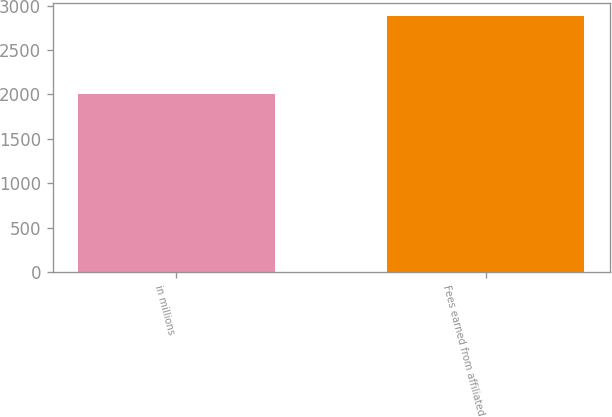<chart> <loc_0><loc_0><loc_500><loc_500><bar_chart><fcel>in millions<fcel>Fees earned from affiliated<nl><fcel>2010<fcel>2882<nl></chart> 